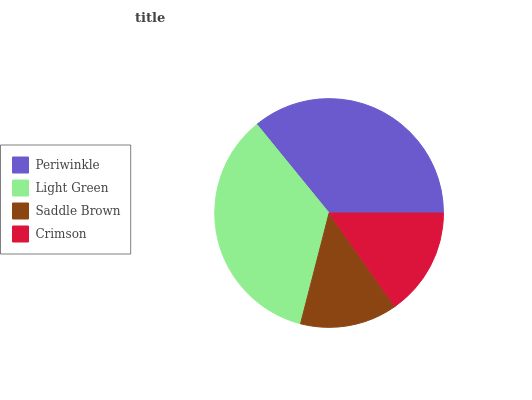Is Saddle Brown the minimum?
Answer yes or no. Yes. Is Periwinkle the maximum?
Answer yes or no. Yes. Is Light Green the minimum?
Answer yes or no. No. Is Light Green the maximum?
Answer yes or no. No. Is Periwinkle greater than Light Green?
Answer yes or no. Yes. Is Light Green less than Periwinkle?
Answer yes or no. Yes. Is Light Green greater than Periwinkle?
Answer yes or no. No. Is Periwinkle less than Light Green?
Answer yes or no. No. Is Light Green the high median?
Answer yes or no. Yes. Is Crimson the low median?
Answer yes or no. Yes. Is Crimson the high median?
Answer yes or no. No. Is Light Green the low median?
Answer yes or no. No. 